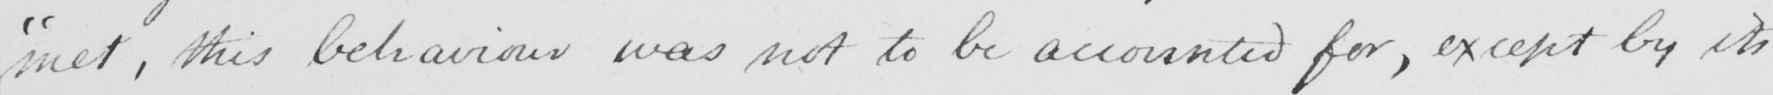Please provide the text content of this handwritten line. " met , this behaviour was not to be accounted for , except by its 